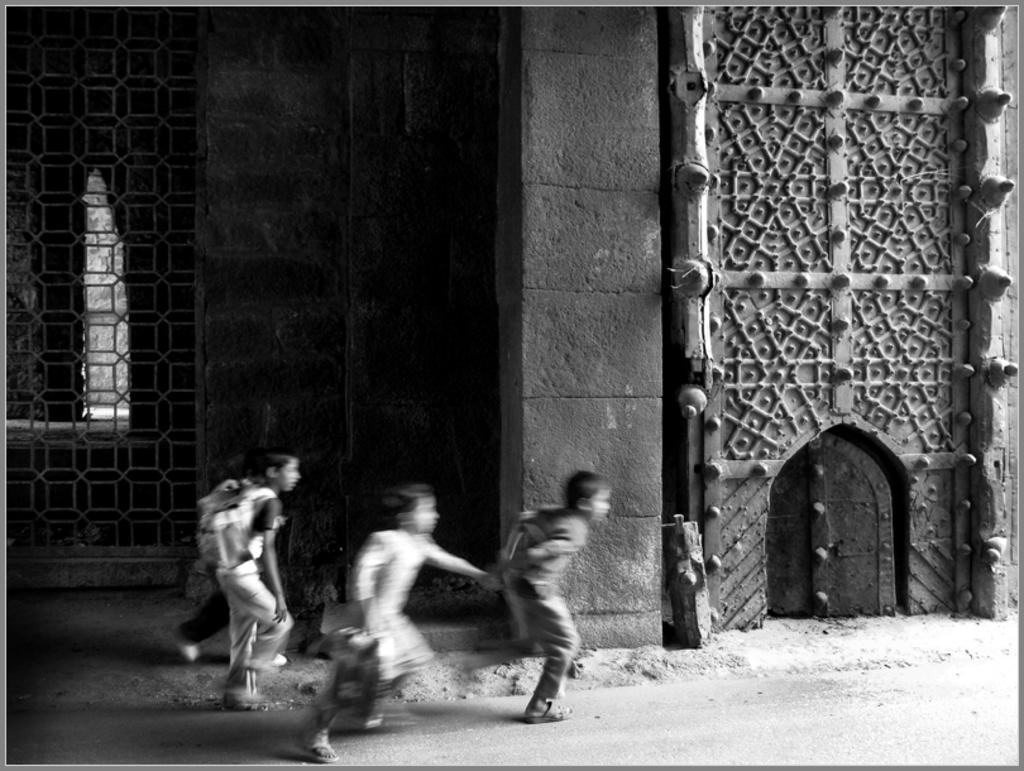What is present in the image? There are kids in the image. What are the kids doing? The kids are running. What can be seen in the background of the image? There is a building in the background of the image. What type of cookware is being used by the kids in the image? There is no cookware present in the image; the kids are running. What game are the kids playing in the image? The image does not show the kids playing a specific game; they are simply running. 